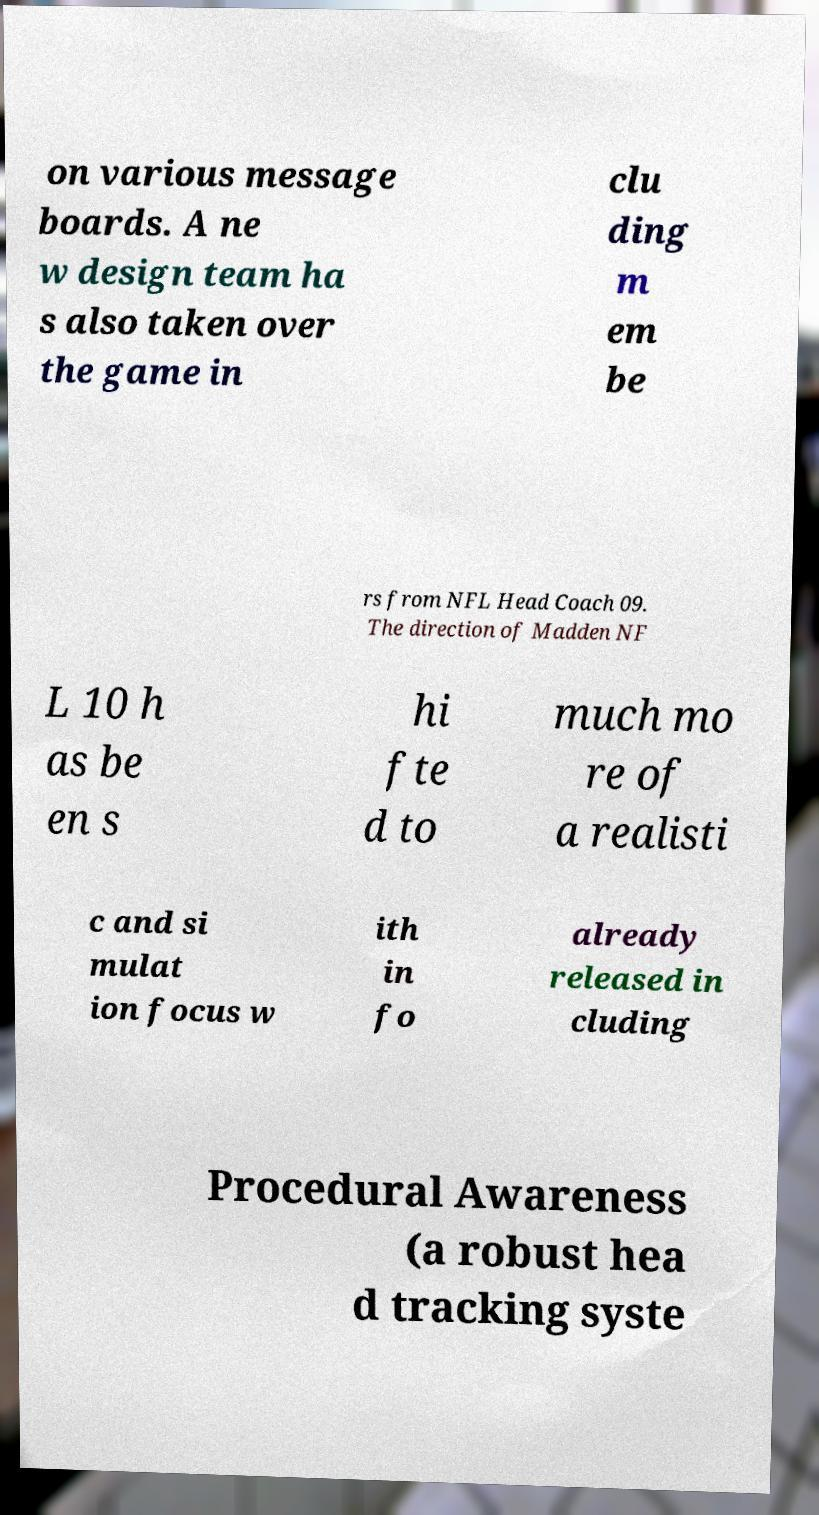Can you read and provide the text displayed in the image?This photo seems to have some interesting text. Can you extract and type it out for me? on various message boards. A ne w design team ha s also taken over the game in clu ding m em be rs from NFL Head Coach 09. The direction of Madden NF L 10 h as be en s hi fte d to much mo re of a realisti c and si mulat ion focus w ith in fo already released in cluding Procedural Awareness (a robust hea d tracking syste 